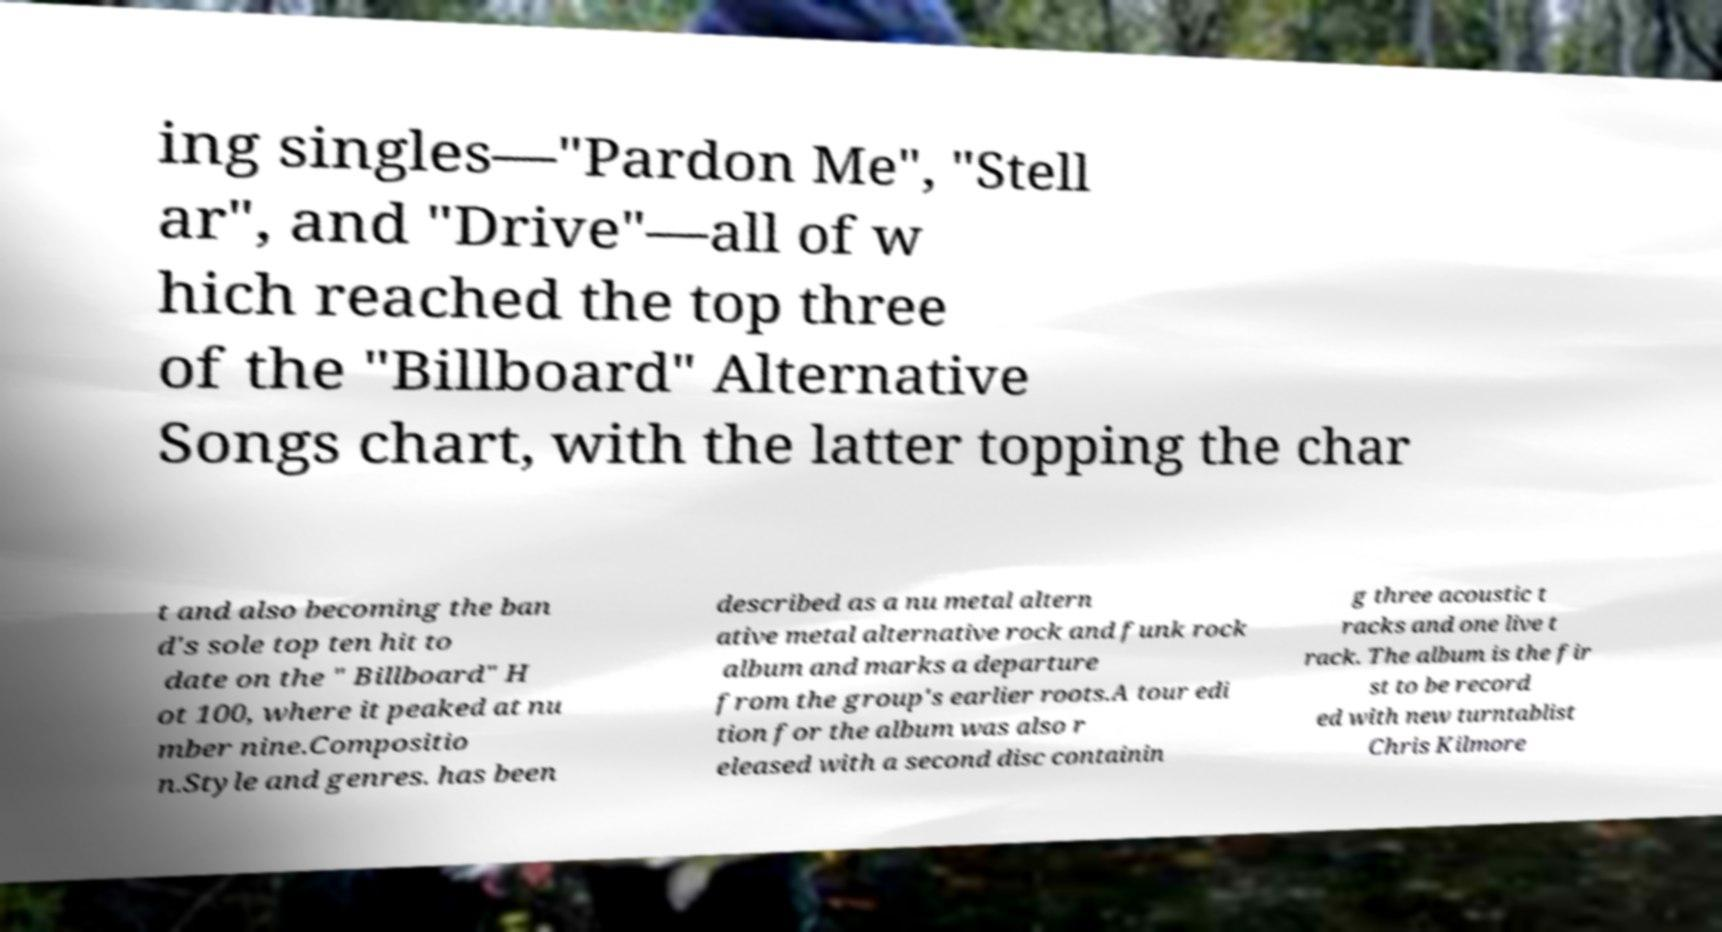Can you accurately transcribe the text from the provided image for me? ing singles—"Pardon Me", "Stell ar", and "Drive"—all of w hich reached the top three of the "Billboard" Alternative Songs chart, with the latter topping the char t and also becoming the ban d's sole top ten hit to date on the " Billboard" H ot 100, where it peaked at nu mber nine.Compositio n.Style and genres. has been described as a nu metal altern ative metal alternative rock and funk rock album and marks a departure from the group's earlier roots.A tour edi tion for the album was also r eleased with a second disc containin g three acoustic t racks and one live t rack. The album is the fir st to be record ed with new turntablist Chris Kilmore 